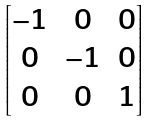<formula> <loc_0><loc_0><loc_500><loc_500>\begin{bmatrix} - 1 & 0 & 0 \\ 0 & - 1 & 0 \\ 0 & 0 & 1 \\ \end{bmatrix}</formula> 